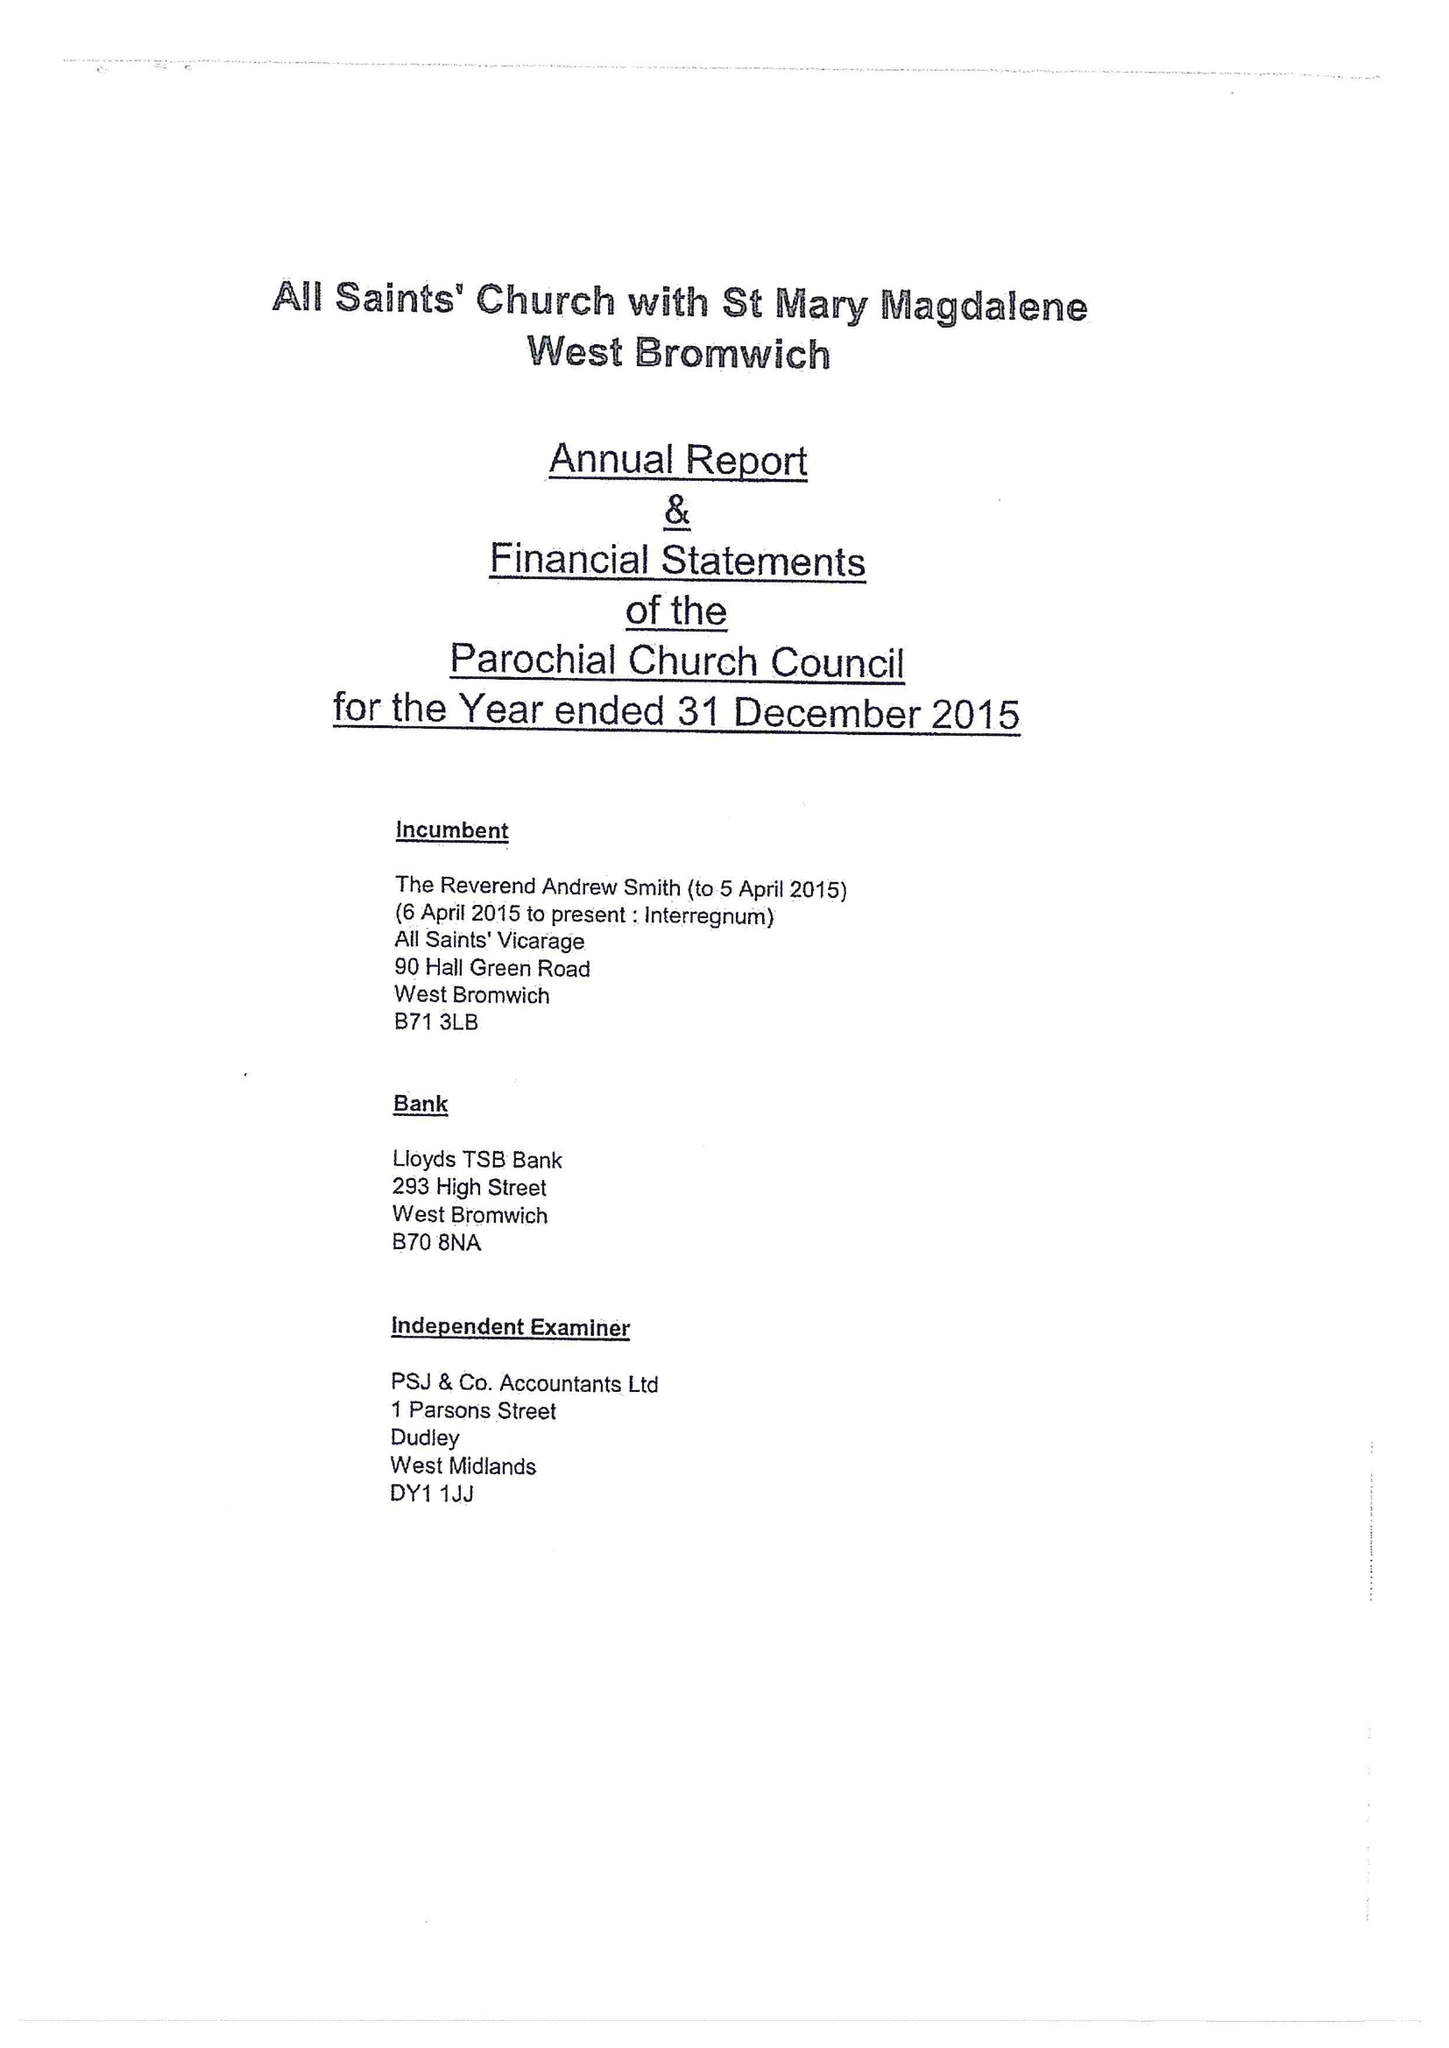What is the value for the address__postcode?
Answer the question using a single word or phrase. B43 6HU 